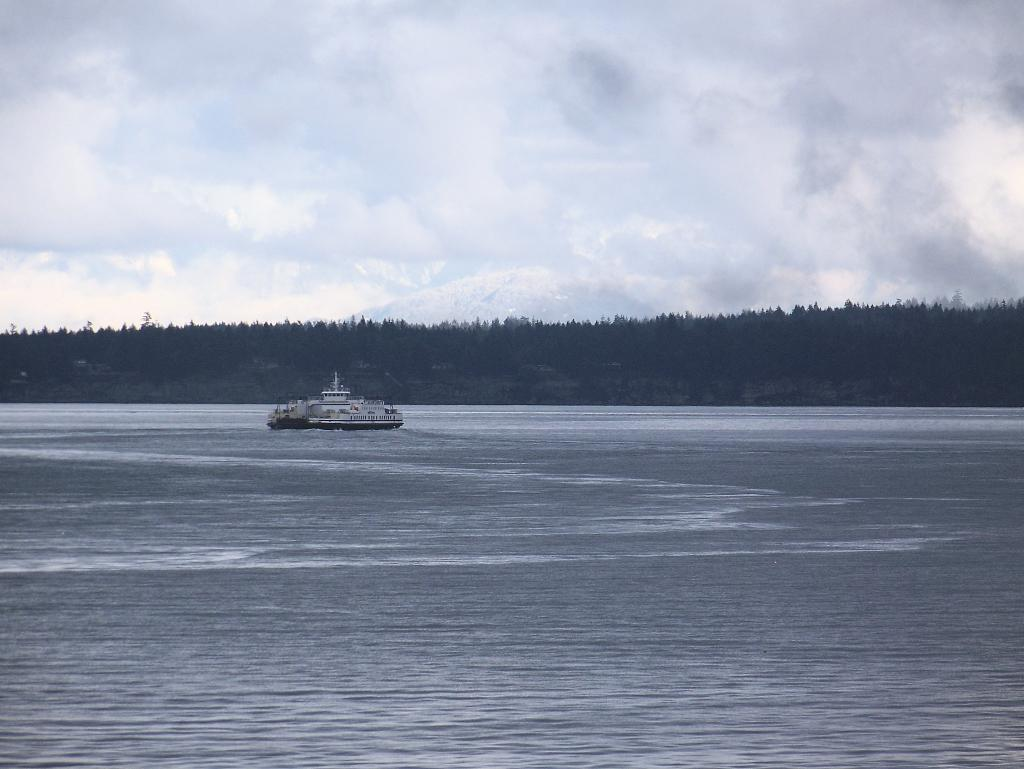What is the main subject of the image? The main subject of the image is a ship sailing on the water. What type of environment is the ship in? The ship is sailing on a water surface. What can be seen in the background of the image? There are trees visible in the background of the image. How many books are on the ship in the image? There are no books visible in the image; it features a ship sailing on a water surface with trees in the background. Are there any spiders crawling on the ship in the image? There are no spiders visible in the image; it features a ship sailing on a water surface with trees in the background. 